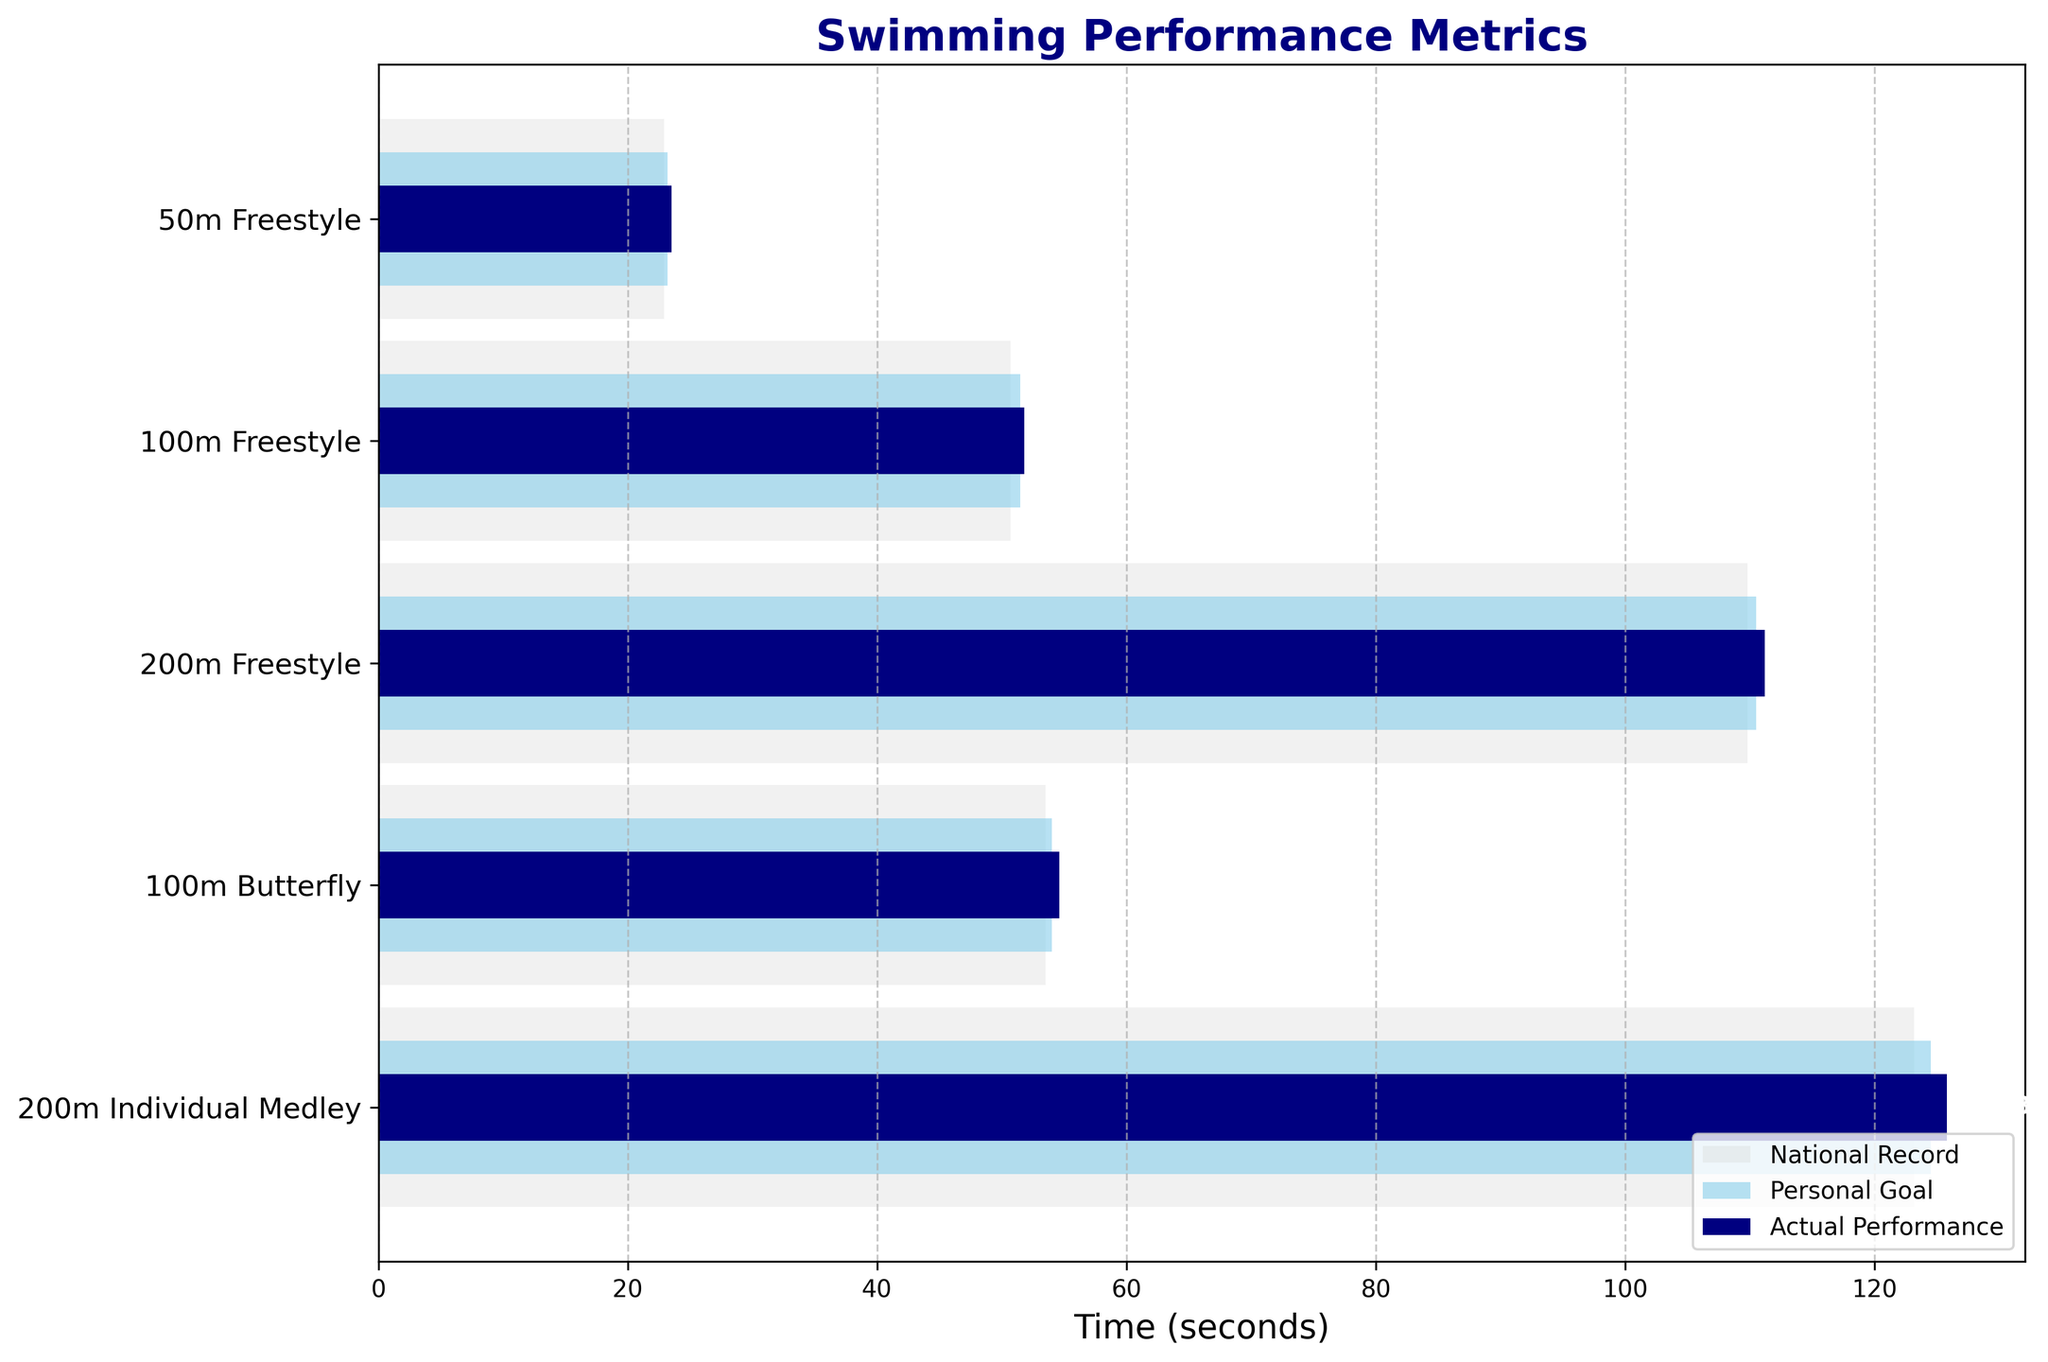What's the title of the figure? The title is located at the top center of the figure and is displayed in navy font.
Answer: Swimming Performance Metrics How many events are shown in the figure? Count the number of different events listed along the vertical axis.
Answer: 5 What is the actual performance time for the 50m Freestyle? Look at the horizontal navy bar corresponding to the 50m Freestyle event, and read the value next to it.
Answer: 23.5 seconds Is the personal goal for the 100m Butterfly below the national record? Compare the lengths of the skyblue (Personal Goal) and lightgrey (National Record) bars for the 100m Butterfly event.
Answer: Yes Which event has the largest gap between the actual performance and the personal goal? Find the event with the largest difference between the navy (Actual Performance) bar and the skyblue (Personal Goal) bar by visually comparing the distances between the ends of these bars.
Answer: 200m Individual Medley What is the difference between the actual performance and the personal goal in the 100m Freestyle? Find the horizontal navy and skyblue bars for the 100m Freestyle event, then subtract the goal (skyblue) value from the actual performance (navy) value.
Answer: 0.3 seconds Which event is closest to achieving the national record based on actual performance? Identify the event where the actual performance (navy bar) is closest to the national record (light grey bar).
Answer: 50m Freestyle Rank the events from best to worst performance based on how close the actual performance is to the personal goal. For each event, calculate the difference between the actual performance (navy bar) and the personal goal (skyblue bar), then rank the events in ascending order of these differences.
Answer: 50m Freestyle, 100m Freestyle, 100m Butterfly, 200m Freestyle, 200m Individual Medley Did the actual performance for any event meet the personal goal? Check if any navy bar (Actual Performance) is equal to or shorter than the corresponding skyblue bar (Personal Goal) for each event.
Answer: No How much faster is the national record compared to the personal goal in the 200m Freestyle? Find the horizontal lightgrey and skyblue bars for the 200m Freestyle event and subtract the national record (lightgrey) value from the personal goal (skyblue) value.
Answer: 0.7 seconds 